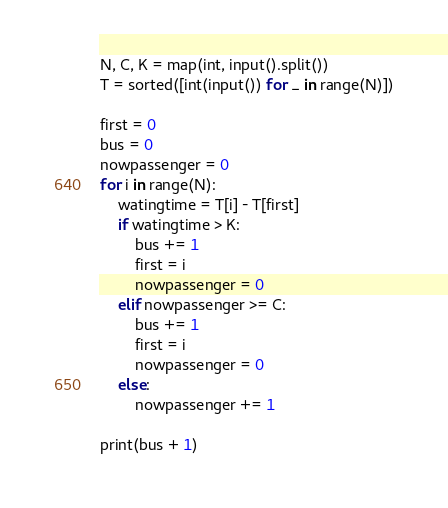<code> <loc_0><loc_0><loc_500><loc_500><_Python_>N, C, K = map(int, input().split())
T = sorted([int(input()) for _ in range(N)])

first = 0
bus = 0
nowpassenger = 0
for i in range(N):
    watingtime = T[i] - T[first]
    if watingtime > K:
        bus += 1
        first = i
        nowpassenger = 0
    elif nowpassenger >= C:
        bus += 1
        first = i
        nowpassenger = 0
    else:
        nowpassenger += 1

print(bus + 1)
</code> 